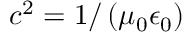Convert formula to latex. <formula><loc_0><loc_0><loc_500><loc_500>c ^ { 2 } = 1 / \left ( \mu _ { 0 } \epsilon _ { 0 } \right )</formula> 